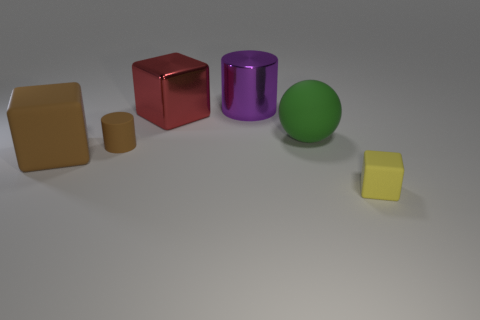Subtract all red metallic cubes. How many cubes are left? 2 Add 1 small cyan rubber objects. How many objects exist? 7 Subtract all brown blocks. How many blocks are left? 2 Subtract all balls. How many objects are left? 5 Subtract 2 cubes. How many cubes are left? 1 Add 1 green things. How many green things are left? 2 Add 5 tiny yellow matte cubes. How many tiny yellow matte cubes exist? 6 Subtract 0 cyan blocks. How many objects are left? 6 Subtract all brown cylinders. Subtract all cyan spheres. How many cylinders are left? 1 Subtract all purple blocks. How many brown cylinders are left? 1 